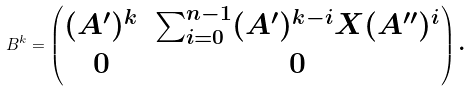<formula> <loc_0><loc_0><loc_500><loc_500>B ^ { k } = \begin{pmatrix} ( A ^ { \prime } ) ^ { k } & \sum _ { i = 0 } ^ { n - 1 } ( A ^ { \prime } ) ^ { k - i } X ( A ^ { \prime \prime } ) ^ { i } \\ 0 & 0 \end{pmatrix} \text {.}</formula> 